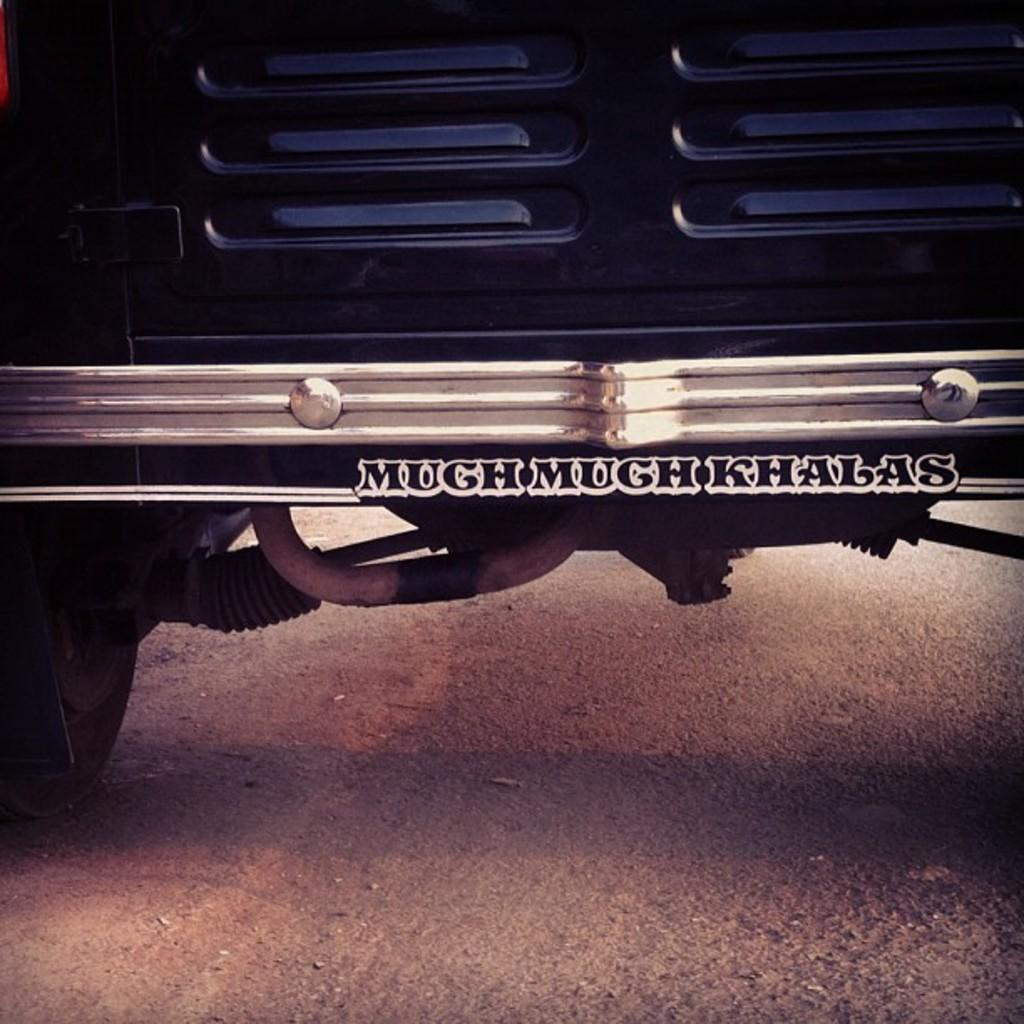What is the main subject of the image? The main subject of the image is an auto. Where is the auto located in the image? The auto is on the road in the image. What is present in the center of the auto? There is text or an image in the center of the auto. How many wheels can be seen on the auto? There is a wheel on the left side of the auto. Can you tell me how many frogs are sitting on the knife in the image? There are no frogs or knives present in the image; it features an auto on the road with a wheel and text or an image in the center. 